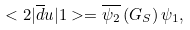<formula> <loc_0><loc_0><loc_500><loc_500>< 2 | \overline { d } u | 1 > = \overline { \psi _ { 2 } } \left ( G _ { S } \right ) \psi _ { 1 } ,</formula> 